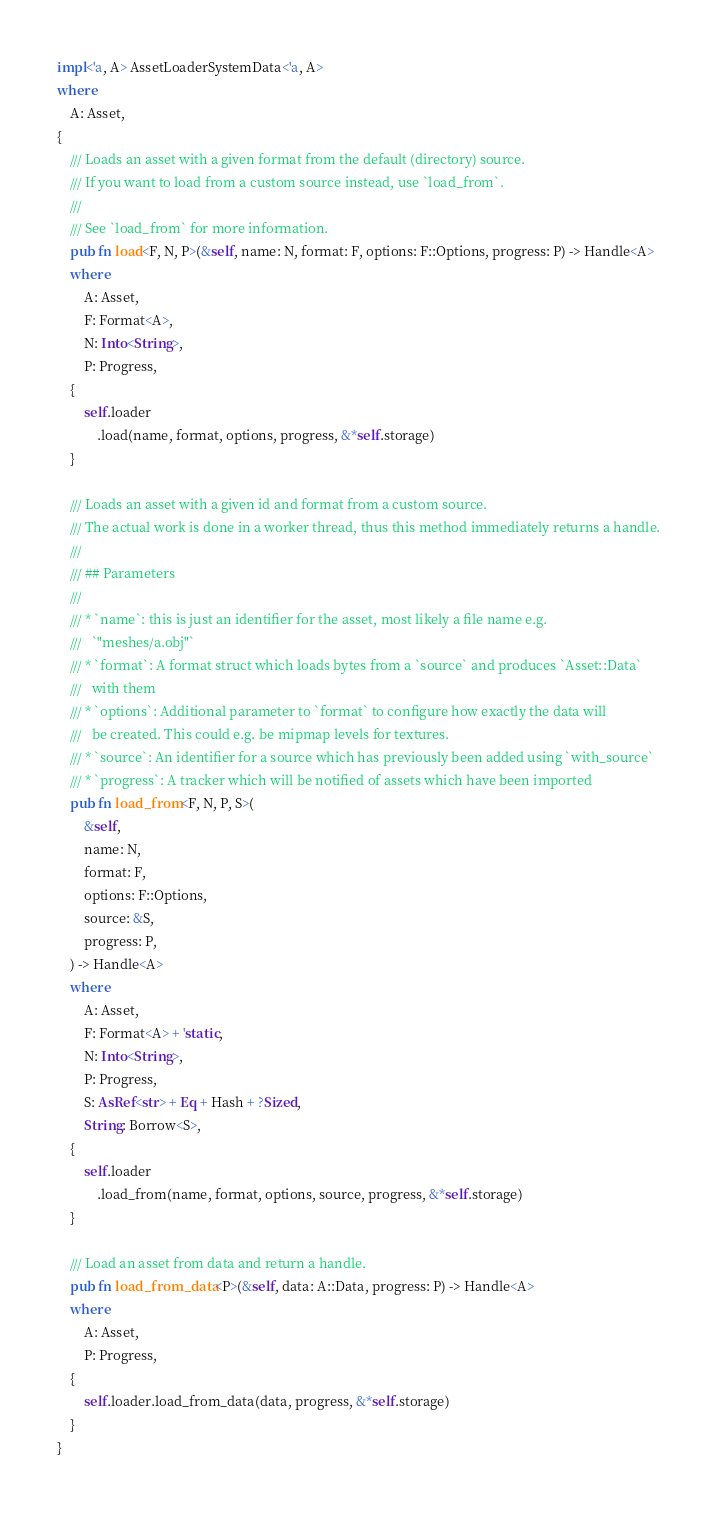<code> <loc_0><loc_0><loc_500><loc_500><_Rust_>
impl<'a, A> AssetLoaderSystemData<'a, A>
where
    A: Asset,
{
    /// Loads an asset with a given format from the default (directory) source.
    /// If you want to load from a custom source instead, use `load_from`.
    ///
    /// See `load_from` for more information.
    pub fn load<F, N, P>(&self, name: N, format: F, options: F::Options, progress: P) -> Handle<A>
    where
        A: Asset,
        F: Format<A>,
        N: Into<String>,
        P: Progress,
    {
        self.loader
            .load(name, format, options, progress, &*self.storage)
    }

    /// Loads an asset with a given id and format from a custom source.
    /// The actual work is done in a worker thread, thus this method immediately returns a handle.
    ///
    /// ## Parameters
    ///
    /// * `name`: this is just an identifier for the asset, most likely a file name e.g.
    ///   `"meshes/a.obj"`
    /// * `format`: A format struct which loads bytes from a `source` and produces `Asset::Data`
    ///   with them
    /// * `options`: Additional parameter to `format` to configure how exactly the data will
    ///   be created. This could e.g. be mipmap levels for textures.
    /// * `source`: An identifier for a source which has previously been added using `with_source`
    /// * `progress`: A tracker which will be notified of assets which have been imported
    pub fn load_from<F, N, P, S>(
        &self,
        name: N,
        format: F,
        options: F::Options,
        source: &S,
        progress: P,
    ) -> Handle<A>
    where
        A: Asset,
        F: Format<A> + 'static,
        N: Into<String>,
        P: Progress,
        S: AsRef<str> + Eq + Hash + ?Sized,
        String: Borrow<S>,
    {
        self.loader
            .load_from(name, format, options, source, progress, &*self.storage)
    }

    /// Load an asset from data and return a handle.
    pub fn load_from_data<P>(&self, data: A::Data, progress: P) -> Handle<A>
    where
        A: Asset,
        P: Progress,
    {
        self.loader.load_from_data(data, progress, &*self.storage)
    }
}
</code> 